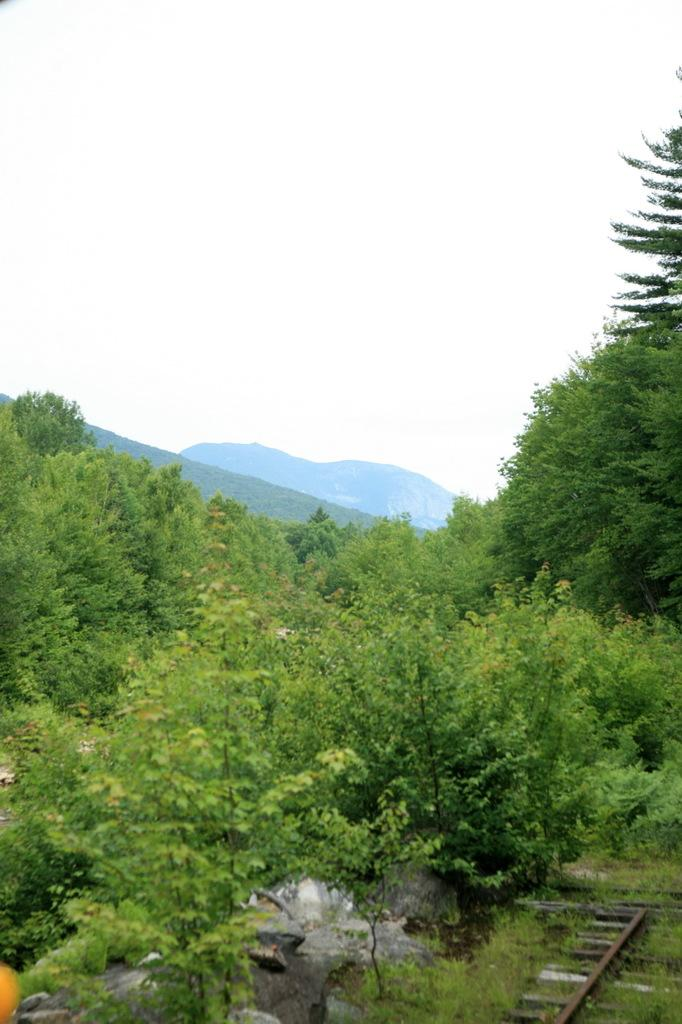What is located in front of the image? There are trees, rocks, and a metal object in front of the image. What can be seen in the background of the image? There are mountains in the background of the image. What is visible at the top of the image? The sky is visible at the top of the image. Can you see a volleyball being played in the image? There is no volleyball or any indication of a game being played in the image. What type of paper is being used to write in the image? There is no paper or writing present in the image. 